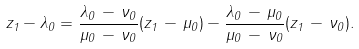<formula> <loc_0><loc_0><loc_500><loc_500>z _ { 1 } - \lambda _ { 0 } = \frac { \lambda _ { 0 } \, - \, \nu _ { 0 } } { \mu _ { 0 } \, - \, \nu _ { 0 } } ( z _ { 1 } \, - \, \mu _ { 0 } ) - \frac { \lambda _ { 0 } \, - \, \mu _ { 0 } } { \mu _ { 0 } \, - \, \nu _ { 0 } } ( z _ { 1 } \, - \, \nu _ { 0 } ) .</formula> 